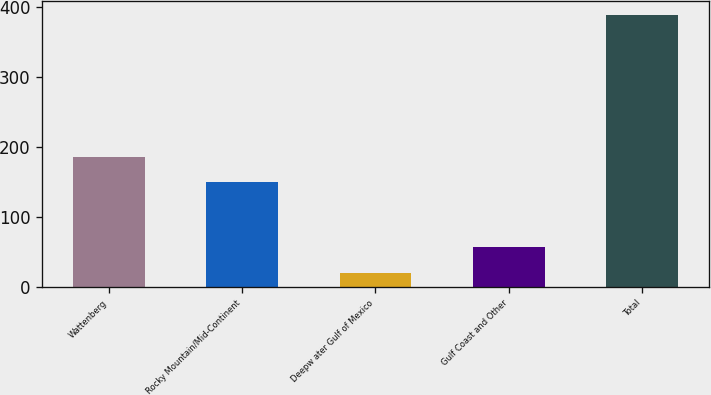<chart> <loc_0><loc_0><loc_500><loc_500><bar_chart><fcel>Wattenberg<fcel>Rocky Mountain/Mid-Continent<fcel>Deepw ater Gulf of Mexico<fcel>Gulf Coast and Other<fcel>Total<nl><fcel>185.8<fcel>149<fcel>20<fcel>56.8<fcel>388<nl></chart> 